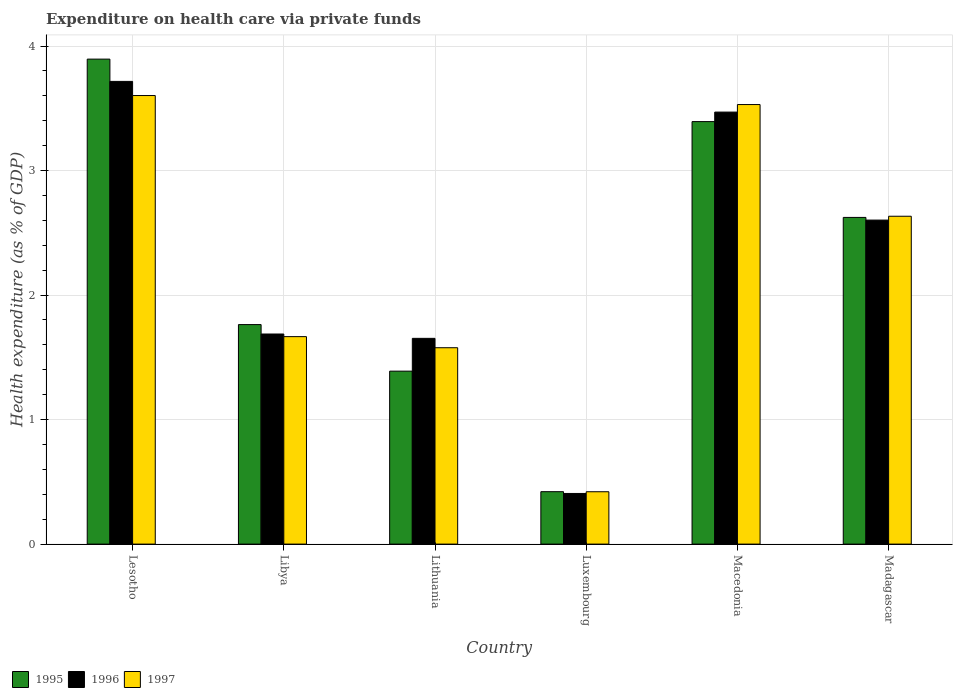How many bars are there on the 1st tick from the left?
Ensure brevity in your answer.  3. How many bars are there on the 6th tick from the right?
Ensure brevity in your answer.  3. What is the label of the 2nd group of bars from the left?
Provide a short and direct response. Libya. What is the expenditure made on health care in 1996 in Macedonia?
Keep it short and to the point. 3.47. Across all countries, what is the maximum expenditure made on health care in 1995?
Ensure brevity in your answer.  3.89. Across all countries, what is the minimum expenditure made on health care in 1997?
Your answer should be very brief. 0.42. In which country was the expenditure made on health care in 1996 maximum?
Give a very brief answer. Lesotho. In which country was the expenditure made on health care in 1996 minimum?
Offer a terse response. Luxembourg. What is the total expenditure made on health care in 1997 in the graph?
Your response must be concise. 13.43. What is the difference between the expenditure made on health care in 1997 in Lithuania and that in Luxembourg?
Your answer should be compact. 1.16. What is the difference between the expenditure made on health care in 1996 in Macedonia and the expenditure made on health care in 1997 in Libya?
Provide a short and direct response. 1.8. What is the average expenditure made on health care in 1995 per country?
Keep it short and to the point. 2.25. What is the difference between the expenditure made on health care of/in 1997 and expenditure made on health care of/in 1995 in Lithuania?
Your response must be concise. 0.19. What is the ratio of the expenditure made on health care in 1996 in Lithuania to that in Luxembourg?
Ensure brevity in your answer.  4.06. Is the expenditure made on health care in 1995 in Libya less than that in Madagascar?
Ensure brevity in your answer.  Yes. What is the difference between the highest and the second highest expenditure made on health care in 1996?
Make the answer very short. 0.87. What is the difference between the highest and the lowest expenditure made on health care in 1996?
Offer a very short reply. 3.31. Is the sum of the expenditure made on health care in 1996 in Lithuania and Macedonia greater than the maximum expenditure made on health care in 1997 across all countries?
Your answer should be very brief. Yes. What does the 3rd bar from the right in Luxembourg represents?
Offer a very short reply. 1995. How many bars are there?
Offer a terse response. 18. Are the values on the major ticks of Y-axis written in scientific E-notation?
Give a very brief answer. No. How are the legend labels stacked?
Offer a terse response. Horizontal. What is the title of the graph?
Keep it short and to the point. Expenditure on health care via private funds. Does "1995" appear as one of the legend labels in the graph?
Provide a short and direct response. Yes. What is the label or title of the X-axis?
Keep it short and to the point. Country. What is the label or title of the Y-axis?
Keep it short and to the point. Health expenditure (as % of GDP). What is the Health expenditure (as % of GDP) in 1995 in Lesotho?
Offer a very short reply. 3.89. What is the Health expenditure (as % of GDP) of 1996 in Lesotho?
Your response must be concise. 3.72. What is the Health expenditure (as % of GDP) in 1997 in Lesotho?
Keep it short and to the point. 3.6. What is the Health expenditure (as % of GDP) of 1995 in Libya?
Ensure brevity in your answer.  1.76. What is the Health expenditure (as % of GDP) of 1996 in Libya?
Offer a very short reply. 1.69. What is the Health expenditure (as % of GDP) in 1997 in Libya?
Provide a short and direct response. 1.67. What is the Health expenditure (as % of GDP) of 1995 in Lithuania?
Ensure brevity in your answer.  1.39. What is the Health expenditure (as % of GDP) in 1996 in Lithuania?
Keep it short and to the point. 1.65. What is the Health expenditure (as % of GDP) in 1997 in Lithuania?
Make the answer very short. 1.58. What is the Health expenditure (as % of GDP) of 1995 in Luxembourg?
Make the answer very short. 0.42. What is the Health expenditure (as % of GDP) of 1996 in Luxembourg?
Your response must be concise. 0.41. What is the Health expenditure (as % of GDP) in 1997 in Luxembourg?
Provide a succinct answer. 0.42. What is the Health expenditure (as % of GDP) in 1995 in Macedonia?
Make the answer very short. 3.39. What is the Health expenditure (as % of GDP) of 1996 in Macedonia?
Ensure brevity in your answer.  3.47. What is the Health expenditure (as % of GDP) in 1997 in Macedonia?
Provide a succinct answer. 3.53. What is the Health expenditure (as % of GDP) of 1995 in Madagascar?
Offer a very short reply. 2.62. What is the Health expenditure (as % of GDP) in 1996 in Madagascar?
Provide a short and direct response. 2.6. What is the Health expenditure (as % of GDP) of 1997 in Madagascar?
Your answer should be very brief. 2.63. Across all countries, what is the maximum Health expenditure (as % of GDP) of 1995?
Give a very brief answer. 3.89. Across all countries, what is the maximum Health expenditure (as % of GDP) in 1996?
Your answer should be compact. 3.72. Across all countries, what is the maximum Health expenditure (as % of GDP) of 1997?
Provide a short and direct response. 3.6. Across all countries, what is the minimum Health expenditure (as % of GDP) of 1995?
Ensure brevity in your answer.  0.42. Across all countries, what is the minimum Health expenditure (as % of GDP) of 1996?
Give a very brief answer. 0.41. Across all countries, what is the minimum Health expenditure (as % of GDP) of 1997?
Provide a succinct answer. 0.42. What is the total Health expenditure (as % of GDP) of 1995 in the graph?
Keep it short and to the point. 13.48. What is the total Health expenditure (as % of GDP) of 1996 in the graph?
Provide a short and direct response. 13.53. What is the total Health expenditure (as % of GDP) in 1997 in the graph?
Your answer should be very brief. 13.43. What is the difference between the Health expenditure (as % of GDP) of 1995 in Lesotho and that in Libya?
Provide a short and direct response. 2.13. What is the difference between the Health expenditure (as % of GDP) of 1996 in Lesotho and that in Libya?
Provide a succinct answer. 2.03. What is the difference between the Health expenditure (as % of GDP) of 1997 in Lesotho and that in Libya?
Offer a very short reply. 1.94. What is the difference between the Health expenditure (as % of GDP) in 1995 in Lesotho and that in Lithuania?
Your response must be concise. 2.51. What is the difference between the Health expenditure (as % of GDP) of 1996 in Lesotho and that in Lithuania?
Ensure brevity in your answer.  2.06. What is the difference between the Health expenditure (as % of GDP) in 1997 in Lesotho and that in Lithuania?
Your answer should be very brief. 2.03. What is the difference between the Health expenditure (as % of GDP) in 1995 in Lesotho and that in Luxembourg?
Provide a succinct answer. 3.47. What is the difference between the Health expenditure (as % of GDP) of 1996 in Lesotho and that in Luxembourg?
Your answer should be very brief. 3.31. What is the difference between the Health expenditure (as % of GDP) in 1997 in Lesotho and that in Luxembourg?
Make the answer very short. 3.18. What is the difference between the Health expenditure (as % of GDP) in 1995 in Lesotho and that in Macedonia?
Give a very brief answer. 0.5. What is the difference between the Health expenditure (as % of GDP) of 1996 in Lesotho and that in Macedonia?
Provide a succinct answer. 0.25. What is the difference between the Health expenditure (as % of GDP) of 1997 in Lesotho and that in Macedonia?
Make the answer very short. 0.07. What is the difference between the Health expenditure (as % of GDP) of 1995 in Lesotho and that in Madagascar?
Keep it short and to the point. 1.27. What is the difference between the Health expenditure (as % of GDP) of 1996 in Lesotho and that in Madagascar?
Provide a succinct answer. 1.11. What is the difference between the Health expenditure (as % of GDP) in 1997 in Lesotho and that in Madagascar?
Provide a short and direct response. 0.97. What is the difference between the Health expenditure (as % of GDP) of 1995 in Libya and that in Lithuania?
Provide a short and direct response. 0.37. What is the difference between the Health expenditure (as % of GDP) in 1996 in Libya and that in Lithuania?
Give a very brief answer. 0.03. What is the difference between the Health expenditure (as % of GDP) of 1997 in Libya and that in Lithuania?
Your response must be concise. 0.09. What is the difference between the Health expenditure (as % of GDP) in 1995 in Libya and that in Luxembourg?
Give a very brief answer. 1.34. What is the difference between the Health expenditure (as % of GDP) in 1996 in Libya and that in Luxembourg?
Keep it short and to the point. 1.28. What is the difference between the Health expenditure (as % of GDP) of 1997 in Libya and that in Luxembourg?
Ensure brevity in your answer.  1.25. What is the difference between the Health expenditure (as % of GDP) of 1995 in Libya and that in Macedonia?
Offer a terse response. -1.63. What is the difference between the Health expenditure (as % of GDP) in 1996 in Libya and that in Macedonia?
Ensure brevity in your answer.  -1.78. What is the difference between the Health expenditure (as % of GDP) of 1997 in Libya and that in Macedonia?
Your response must be concise. -1.86. What is the difference between the Health expenditure (as % of GDP) of 1995 in Libya and that in Madagascar?
Give a very brief answer. -0.86. What is the difference between the Health expenditure (as % of GDP) in 1996 in Libya and that in Madagascar?
Give a very brief answer. -0.91. What is the difference between the Health expenditure (as % of GDP) in 1997 in Libya and that in Madagascar?
Ensure brevity in your answer.  -0.97. What is the difference between the Health expenditure (as % of GDP) in 1995 in Lithuania and that in Luxembourg?
Give a very brief answer. 0.97. What is the difference between the Health expenditure (as % of GDP) in 1996 in Lithuania and that in Luxembourg?
Provide a succinct answer. 1.25. What is the difference between the Health expenditure (as % of GDP) in 1997 in Lithuania and that in Luxembourg?
Your answer should be compact. 1.16. What is the difference between the Health expenditure (as % of GDP) of 1995 in Lithuania and that in Macedonia?
Make the answer very short. -2. What is the difference between the Health expenditure (as % of GDP) in 1996 in Lithuania and that in Macedonia?
Your answer should be compact. -1.82. What is the difference between the Health expenditure (as % of GDP) in 1997 in Lithuania and that in Macedonia?
Give a very brief answer. -1.95. What is the difference between the Health expenditure (as % of GDP) in 1995 in Lithuania and that in Madagascar?
Your response must be concise. -1.23. What is the difference between the Health expenditure (as % of GDP) of 1996 in Lithuania and that in Madagascar?
Make the answer very short. -0.95. What is the difference between the Health expenditure (as % of GDP) of 1997 in Lithuania and that in Madagascar?
Keep it short and to the point. -1.06. What is the difference between the Health expenditure (as % of GDP) of 1995 in Luxembourg and that in Macedonia?
Make the answer very short. -2.97. What is the difference between the Health expenditure (as % of GDP) of 1996 in Luxembourg and that in Macedonia?
Ensure brevity in your answer.  -3.06. What is the difference between the Health expenditure (as % of GDP) in 1997 in Luxembourg and that in Macedonia?
Give a very brief answer. -3.11. What is the difference between the Health expenditure (as % of GDP) in 1995 in Luxembourg and that in Madagascar?
Your answer should be compact. -2.2. What is the difference between the Health expenditure (as % of GDP) in 1996 in Luxembourg and that in Madagascar?
Your answer should be very brief. -2.2. What is the difference between the Health expenditure (as % of GDP) of 1997 in Luxembourg and that in Madagascar?
Offer a terse response. -2.21. What is the difference between the Health expenditure (as % of GDP) in 1995 in Macedonia and that in Madagascar?
Provide a short and direct response. 0.77. What is the difference between the Health expenditure (as % of GDP) of 1996 in Macedonia and that in Madagascar?
Your response must be concise. 0.87. What is the difference between the Health expenditure (as % of GDP) of 1997 in Macedonia and that in Madagascar?
Give a very brief answer. 0.9. What is the difference between the Health expenditure (as % of GDP) in 1995 in Lesotho and the Health expenditure (as % of GDP) in 1996 in Libya?
Provide a short and direct response. 2.21. What is the difference between the Health expenditure (as % of GDP) in 1995 in Lesotho and the Health expenditure (as % of GDP) in 1997 in Libya?
Make the answer very short. 2.23. What is the difference between the Health expenditure (as % of GDP) of 1996 in Lesotho and the Health expenditure (as % of GDP) of 1997 in Libya?
Provide a short and direct response. 2.05. What is the difference between the Health expenditure (as % of GDP) in 1995 in Lesotho and the Health expenditure (as % of GDP) in 1996 in Lithuania?
Your response must be concise. 2.24. What is the difference between the Health expenditure (as % of GDP) of 1995 in Lesotho and the Health expenditure (as % of GDP) of 1997 in Lithuania?
Your answer should be compact. 2.32. What is the difference between the Health expenditure (as % of GDP) in 1996 in Lesotho and the Health expenditure (as % of GDP) in 1997 in Lithuania?
Provide a short and direct response. 2.14. What is the difference between the Health expenditure (as % of GDP) of 1995 in Lesotho and the Health expenditure (as % of GDP) of 1996 in Luxembourg?
Give a very brief answer. 3.49. What is the difference between the Health expenditure (as % of GDP) in 1995 in Lesotho and the Health expenditure (as % of GDP) in 1997 in Luxembourg?
Offer a terse response. 3.47. What is the difference between the Health expenditure (as % of GDP) in 1996 in Lesotho and the Health expenditure (as % of GDP) in 1997 in Luxembourg?
Ensure brevity in your answer.  3.3. What is the difference between the Health expenditure (as % of GDP) of 1995 in Lesotho and the Health expenditure (as % of GDP) of 1996 in Macedonia?
Offer a very short reply. 0.43. What is the difference between the Health expenditure (as % of GDP) of 1995 in Lesotho and the Health expenditure (as % of GDP) of 1997 in Macedonia?
Provide a short and direct response. 0.36. What is the difference between the Health expenditure (as % of GDP) in 1996 in Lesotho and the Health expenditure (as % of GDP) in 1997 in Macedonia?
Your answer should be very brief. 0.19. What is the difference between the Health expenditure (as % of GDP) of 1995 in Lesotho and the Health expenditure (as % of GDP) of 1996 in Madagascar?
Make the answer very short. 1.29. What is the difference between the Health expenditure (as % of GDP) in 1995 in Lesotho and the Health expenditure (as % of GDP) in 1997 in Madagascar?
Give a very brief answer. 1.26. What is the difference between the Health expenditure (as % of GDP) of 1996 in Lesotho and the Health expenditure (as % of GDP) of 1997 in Madagascar?
Keep it short and to the point. 1.08. What is the difference between the Health expenditure (as % of GDP) in 1995 in Libya and the Health expenditure (as % of GDP) in 1996 in Lithuania?
Provide a short and direct response. 0.11. What is the difference between the Health expenditure (as % of GDP) of 1995 in Libya and the Health expenditure (as % of GDP) of 1997 in Lithuania?
Keep it short and to the point. 0.19. What is the difference between the Health expenditure (as % of GDP) of 1996 in Libya and the Health expenditure (as % of GDP) of 1997 in Lithuania?
Keep it short and to the point. 0.11. What is the difference between the Health expenditure (as % of GDP) of 1995 in Libya and the Health expenditure (as % of GDP) of 1996 in Luxembourg?
Provide a short and direct response. 1.36. What is the difference between the Health expenditure (as % of GDP) in 1995 in Libya and the Health expenditure (as % of GDP) in 1997 in Luxembourg?
Your answer should be compact. 1.34. What is the difference between the Health expenditure (as % of GDP) in 1996 in Libya and the Health expenditure (as % of GDP) in 1997 in Luxembourg?
Ensure brevity in your answer.  1.27. What is the difference between the Health expenditure (as % of GDP) of 1995 in Libya and the Health expenditure (as % of GDP) of 1996 in Macedonia?
Keep it short and to the point. -1.71. What is the difference between the Health expenditure (as % of GDP) in 1995 in Libya and the Health expenditure (as % of GDP) in 1997 in Macedonia?
Provide a succinct answer. -1.77. What is the difference between the Health expenditure (as % of GDP) in 1996 in Libya and the Health expenditure (as % of GDP) in 1997 in Macedonia?
Ensure brevity in your answer.  -1.84. What is the difference between the Health expenditure (as % of GDP) in 1995 in Libya and the Health expenditure (as % of GDP) in 1996 in Madagascar?
Ensure brevity in your answer.  -0.84. What is the difference between the Health expenditure (as % of GDP) of 1995 in Libya and the Health expenditure (as % of GDP) of 1997 in Madagascar?
Provide a short and direct response. -0.87. What is the difference between the Health expenditure (as % of GDP) in 1996 in Libya and the Health expenditure (as % of GDP) in 1997 in Madagascar?
Offer a very short reply. -0.95. What is the difference between the Health expenditure (as % of GDP) in 1995 in Lithuania and the Health expenditure (as % of GDP) in 1996 in Luxembourg?
Your response must be concise. 0.98. What is the difference between the Health expenditure (as % of GDP) of 1995 in Lithuania and the Health expenditure (as % of GDP) of 1997 in Luxembourg?
Ensure brevity in your answer.  0.97. What is the difference between the Health expenditure (as % of GDP) in 1996 in Lithuania and the Health expenditure (as % of GDP) in 1997 in Luxembourg?
Make the answer very short. 1.23. What is the difference between the Health expenditure (as % of GDP) in 1995 in Lithuania and the Health expenditure (as % of GDP) in 1996 in Macedonia?
Offer a terse response. -2.08. What is the difference between the Health expenditure (as % of GDP) of 1995 in Lithuania and the Health expenditure (as % of GDP) of 1997 in Macedonia?
Offer a very short reply. -2.14. What is the difference between the Health expenditure (as % of GDP) in 1996 in Lithuania and the Health expenditure (as % of GDP) in 1997 in Macedonia?
Offer a very short reply. -1.88. What is the difference between the Health expenditure (as % of GDP) in 1995 in Lithuania and the Health expenditure (as % of GDP) in 1996 in Madagascar?
Ensure brevity in your answer.  -1.21. What is the difference between the Health expenditure (as % of GDP) of 1995 in Lithuania and the Health expenditure (as % of GDP) of 1997 in Madagascar?
Give a very brief answer. -1.24. What is the difference between the Health expenditure (as % of GDP) in 1996 in Lithuania and the Health expenditure (as % of GDP) in 1997 in Madagascar?
Ensure brevity in your answer.  -0.98. What is the difference between the Health expenditure (as % of GDP) of 1995 in Luxembourg and the Health expenditure (as % of GDP) of 1996 in Macedonia?
Offer a terse response. -3.05. What is the difference between the Health expenditure (as % of GDP) of 1995 in Luxembourg and the Health expenditure (as % of GDP) of 1997 in Macedonia?
Offer a terse response. -3.11. What is the difference between the Health expenditure (as % of GDP) in 1996 in Luxembourg and the Health expenditure (as % of GDP) in 1997 in Macedonia?
Offer a very short reply. -3.12. What is the difference between the Health expenditure (as % of GDP) in 1995 in Luxembourg and the Health expenditure (as % of GDP) in 1996 in Madagascar?
Offer a terse response. -2.18. What is the difference between the Health expenditure (as % of GDP) of 1995 in Luxembourg and the Health expenditure (as % of GDP) of 1997 in Madagascar?
Your answer should be very brief. -2.21. What is the difference between the Health expenditure (as % of GDP) in 1996 in Luxembourg and the Health expenditure (as % of GDP) in 1997 in Madagascar?
Your answer should be very brief. -2.23. What is the difference between the Health expenditure (as % of GDP) in 1995 in Macedonia and the Health expenditure (as % of GDP) in 1996 in Madagascar?
Your answer should be very brief. 0.79. What is the difference between the Health expenditure (as % of GDP) of 1995 in Macedonia and the Health expenditure (as % of GDP) of 1997 in Madagascar?
Provide a short and direct response. 0.76. What is the difference between the Health expenditure (as % of GDP) of 1996 in Macedonia and the Health expenditure (as % of GDP) of 1997 in Madagascar?
Give a very brief answer. 0.84. What is the average Health expenditure (as % of GDP) in 1995 per country?
Your response must be concise. 2.25. What is the average Health expenditure (as % of GDP) of 1996 per country?
Your answer should be compact. 2.26. What is the average Health expenditure (as % of GDP) in 1997 per country?
Your response must be concise. 2.24. What is the difference between the Health expenditure (as % of GDP) in 1995 and Health expenditure (as % of GDP) in 1996 in Lesotho?
Provide a short and direct response. 0.18. What is the difference between the Health expenditure (as % of GDP) of 1995 and Health expenditure (as % of GDP) of 1997 in Lesotho?
Offer a terse response. 0.29. What is the difference between the Health expenditure (as % of GDP) in 1996 and Health expenditure (as % of GDP) in 1997 in Lesotho?
Provide a succinct answer. 0.11. What is the difference between the Health expenditure (as % of GDP) in 1995 and Health expenditure (as % of GDP) in 1996 in Libya?
Ensure brevity in your answer.  0.08. What is the difference between the Health expenditure (as % of GDP) in 1995 and Health expenditure (as % of GDP) in 1997 in Libya?
Make the answer very short. 0.1. What is the difference between the Health expenditure (as % of GDP) in 1996 and Health expenditure (as % of GDP) in 1997 in Libya?
Your answer should be very brief. 0.02. What is the difference between the Health expenditure (as % of GDP) in 1995 and Health expenditure (as % of GDP) in 1996 in Lithuania?
Your answer should be very brief. -0.26. What is the difference between the Health expenditure (as % of GDP) of 1995 and Health expenditure (as % of GDP) of 1997 in Lithuania?
Offer a terse response. -0.19. What is the difference between the Health expenditure (as % of GDP) of 1996 and Health expenditure (as % of GDP) of 1997 in Lithuania?
Offer a very short reply. 0.08. What is the difference between the Health expenditure (as % of GDP) of 1995 and Health expenditure (as % of GDP) of 1996 in Luxembourg?
Give a very brief answer. 0.01. What is the difference between the Health expenditure (as % of GDP) in 1995 and Health expenditure (as % of GDP) in 1997 in Luxembourg?
Offer a terse response. 0. What is the difference between the Health expenditure (as % of GDP) in 1996 and Health expenditure (as % of GDP) in 1997 in Luxembourg?
Your response must be concise. -0.01. What is the difference between the Health expenditure (as % of GDP) of 1995 and Health expenditure (as % of GDP) of 1996 in Macedonia?
Make the answer very short. -0.08. What is the difference between the Health expenditure (as % of GDP) of 1995 and Health expenditure (as % of GDP) of 1997 in Macedonia?
Ensure brevity in your answer.  -0.14. What is the difference between the Health expenditure (as % of GDP) of 1996 and Health expenditure (as % of GDP) of 1997 in Macedonia?
Provide a succinct answer. -0.06. What is the difference between the Health expenditure (as % of GDP) of 1995 and Health expenditure (as % of GDP) of 1996 in Madagascar?
Your answer should be compact. 0.02. What is the difference between the Health expenditure (as % of GDP) in 1995 and Health expenditure (as % of GDP) in 1997 in Madagascar?
Ensure brevity in your answer.  -0.01. What is the difference between the Health expenditure (as % of GDP) in 1996 and Health expenditure (as % of GDP) in 1997 in Madagascar?
Your answer should be compact. -0.03. What is the ratio of the Health expenditure (as % of GDP) in 1995 in Lesotho to that in Libya?
Your answer should be compact. 2.21. What is the ratio of the Health expenditure (as % of GDP) in 1996 in Lesotho to that in Libya?
Offer a terse response. 2.2. What is the ratio of the Health expenditure (as % of GDP) in 1997 in Lesotho to that in Libya?
Offer a very short reply. 2.16. What is the ratio of the Health expenditure (as % of GDP) of 1995 in Lesotho to that in Lithuania?
Provide a short and direct response. 2.8. What is the ratio of the Health expenditure (as % of GDP) in 1996 in Lesotho to that in Lithuania?
Provide a succinct answer. 2.25. What is the ratio of the Health expenditure (as % of GDP) in 1997 in Lesotho to that in Lithuania?
Give a very brief answer. 2.28. What is the ratio of the Health expenditure (as % of GDP) of 1995 in Lesotho to that in Luxembourg?
Your answer should be very brief. 9.25. What is the ratio of the Health expenditure (as % of GDP) in 1996 in Lesotho to that in Luxembourg?
Make the answer very short. 9.14. What is the ratio of the Health expenditure (as % of GDP) in 1997 in Lesotho to that in Luxembourg?
Offer a very short reply. 8.57. What is the ratio of the Health expenditure (as % of GDP) in 1995 in Lesotho to that in Macedonia?
Your answer should be very brief. 1.15. What is the ratio of the Health expenditure (as % of GDP) of 1996 in Lesotho to that in Macedonia?
Offer a terse response. 1.07. What is the ratio of the Health expenditure (as % of GDP) in 1997 in Lesotho to that in Macedonia?
Your response must be concise. 1.02. What is the ratio of the Health expenditure (as % of GDP) in 1995 in Lesotho to that in Madagascar?
Keep it short and to the point. 1.48. What is the ratio of the Health expenditure (as % of GDP) in 1996 in Lesotho to that in Madagascar?
Provide a succinct answer. 1.43. What is the ratio of the Health expenditure (as % of GDP) in 1997 in Lesotho to that in Madagascar?
Provide a succinct answer. 1.37. What is the ratio of the Health expenditure (as % of GDP) in 1995 in Libya to that in Lithuania?
Give a very brief answer. 1.27. What is the ratio of the Health expenditure (as % of GDP) in 1996 in Libya to that in Lithuania?
Give a very brief answer. 1.02. What is the ratio of the Health expenditure (as % of GDP) of 1997 in Libya to that in Lithuania?
Your answer should be compact. 1.06. What is the ratio of the Health expenditure (as % of GDP) of 1995 in Libya to that in Luxembourg?
Provide a succinct answer. 4.19. What is the ratio of the Health expenditure (as % of GDP) of 1996 in Libya to that in Luxembourg?
Offer a terse response. 4.15. What is the ratio of the Health expenditure (as % of GDP) of 1997 in Libya to that in Luxembourg?
Offer a terse response. 3.96. What is the ratio of the Health expenditure (as % of GDP) of 1995 in Libya to that in Macedonia?
Your answer should be very brief. 0.52. What is the ratio of the Health expenditure (as % of GDP) in 1996 in Libya to that in Macedonia?
Provide a short and direct response. 0.49. What is the ratio of the Health expenditure (as % of GDP) of 1997 in Libya to that in Macedonia?
Your answer should be very brief. 0.47. What is the ratio of the Health expenditure (as % of GDP) in 1995 in Libya to that in Madagascar?
Your answer should be compact. 0.67. What is the ratio of the Health expenditure (as % of GDP) in 1996 in Libya to that in Madagascar?
Provide a short and direct response. 0.65. What is the ratio of the Health expenditure (as % of GDP) of 1997 in Libya to that in Madagascar?
Your response must be concise. 0.63. What is the ratio of the Health expenditure (as % of GDP) of 1995 in Lithuania to that in Luxembourg?
Provide a succinct answer. 3.3. What is the ratio of the Health expenditure (as % of GDP) of 1996 in Lithuania to that in Luxembourg?
Keep it short and to the point. 4.06. What is the ratio of the Health expenditure (as % of GDP) of 1997 in Lithuania to that in Luxembourg?
Provide a short and direct response. 3.75. What is the ratio of the Health expenditure (as % of GDP) of 1995 in Lithuania to that in Macedonia?
Offer a very short reply. 0.41. What is the ratio of the Health expenditure (as % of GDP) in 1996 in Lithuania to that in Macedonia?
Provide a short and direct response. 0.48. What is the ratio of the Health expenditure (as % of GDP) of 1997 in Lithuania to that in Macedonia?
Your response must be concise. 0.45. What is the ratio of the Health expenditure (as % of GDP) in 1995 in Lithuania to that in Madagascar?
Offer a terse response. 0.53. What is the ratio of the Health expenditure (as % of GDP) in 1996 in Lithuania to that in Madagascar?
Your response must be concise. 0.64. What is the ratio of the Health expenditure (as % of GDP) in 1997 in Lithuania to that in Madagascar?
Provide a succinct answer. 0.6. What is the ratio of the Health expenditure (as % of GDP) in 1995 in Luxembourg to that in Macedonia?
Offer a very short reply. 0.12. What is the ratio of the Health expenditure (as % of GDP) of 1996 in Luxembourg to that in Macedonia?
Your response must be concise. 0.12. What is the ratio of the Health expenditure (as % of GDP) of 1997 in Luxembourg to that in Macedonia?
Provide a succinct answer. 0.12. What is the ratio of the Health expenditure (as % of GDP) of 1995 in Luxembourg to that in Madagascar?
Provide a succinct answer. 0.16. What is the ratio of the Health expenditure (as % of GDP) in 1996 in Luxembourg to that in Madagascar?
Provide a succinct answer. 0.16. What is the ratio of the Health expenditure (as % of GDP) in 1997 in Luxembourg to that in Madagascar?
Ensure brevity in your answer.  0.16. What is the ratio of the Health expenditure (as % of GDP) in 1995 in Macedonia to that in Madagascar?
Offer a very short reply. 1.29. What is the ratio of the Health expenditure (as % of GDP) of 1996 in Macedonia to that in Madagascar?
Your answer should be very brief. 1.33. What is the ratio of the Health expenditure (as % of GDP) of 1997 in Macedonia to that in Madagascar?
Your answer should be compact. 1.34. What is the difference between the highest and the second highest Health expenditure (as % of GDP) of 1995?
Keep it short and to the point. 0.5. What is the difference between the highest and the second highest Health expenditure (as % of GDP) in 1996?
Provide a short and direct response. 0.25. What is the difference between the highest and the second highest Health expenditure (as % of GDP) in 1997?
Offer a very short reply. 0.07. What is the difference between the highest and the lowest Health expenditure (as % of GDP) of 1995?
Your answer should be very brief. 3.47. What is the difference between the highest and the lowest Health expenditure (as % of GDP) in 1996?
Make the answer very short. 3.31. What is the difference between the highest and the lowest Health expenditure (as % of GDP) of 1997?
Provide a succinct answer. 3.18. 